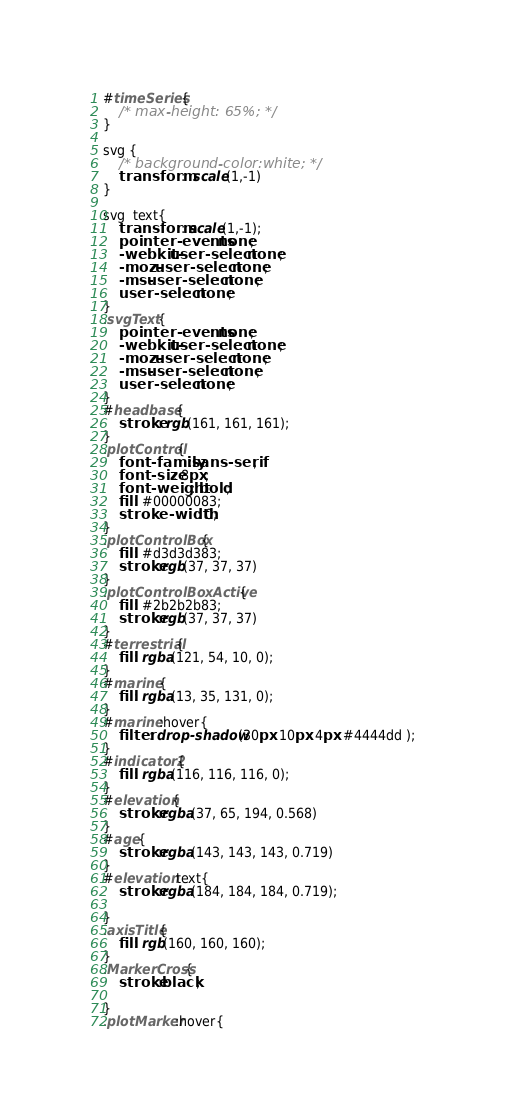<code> <loc_0><loc_0><loc_500><loc_500><_CSS_>#timeSeries{
    /* max-height: 65%; */
}

svg {
    /* background-color:white; */
    transform:  scale(1,-1) 
}

svg  text{
    transform: scale(1,-1);
    pointer-events: none;
    -webkit-user-select: none;
    -moz-user-select: none;
    -ms-user-select: none;
    user-select: none;
}
.svgText {
    pointer-events: none;
    -webkit-user-select: none;
    -moz-user-select: none;
    -ms-user-select: none;
    user-select: none;
}
#headbase{
    stroke: rgb(161, 161, 161);
}
.plotControl{
    font-family:sans-serif;	
    font-size: 8px;
    font-weight: bold;
    fill: #00000083;
    stroke-width: 0;
}
.plotControlBox{
    fill: #d3d3d383;
    stroke:rgb(37, 37, 37)
}
.plotControlBoxActive{
    fill: #2b2b2b83;
    stroke:rgb(37, 37, 37)
}
#terrestrial{
    fill: rgba(121, 54, 10, 0);
}
#marine{
    fill: rgba(13, 35, 131, 0);
}
#marine:hover{
    filter: drop-shadow(30px 10px 4px #4444dd );
}
#indicator2{
    fill: rgba(116, 116, 116, 0);
}
#elevation{
    stroke:rgba(37, 65, 194, 0.568)
}
#age{
    stroke:rgba(143, 143, 143, 0.719)
}
#elevation text{
    stroke:rgba(184, 184, 184, 0.719);

}
.axisTitle{
    fill: rgb(160, 160, 160);
}
.MarkerCross{
    stroke:black;

}
.plotMarker:hover{</code> 